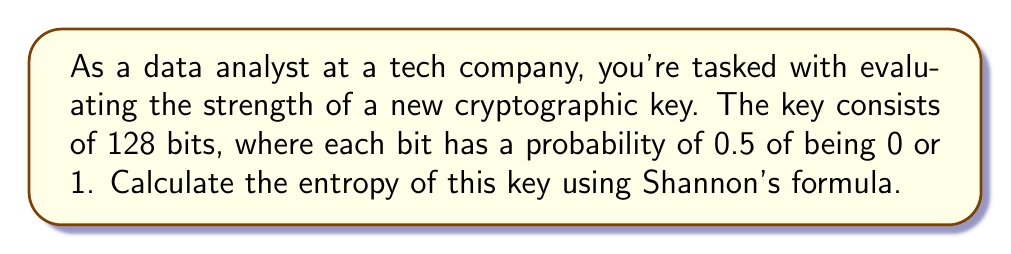Show me your answer to this math problem. To calculate the entropy of the cryptographic key, we'll use Shannon's formula:

$$H = -\sum_{i=1}^n p_i \log_2(p_i)$$

Where:
- $H$ is the entropy in bits
- $p_i$ is the probability of each possible outcome
- $n$ is the number of possible outcomes

For our key:
1. We have 128 bits
2. Each bit has two possible outcomes (0 or 1)
3. The probability of each outcome is 0.5

Let's apply the formula:

$$\begin{align*}
H &= -\sum_{i=1}^2 p_i \log_2(p_i) \\
&= -(0.5 \log_2(0.5) + 0.5 \log_2(0.5)) \\
&= -2(0.5 \log_2(0.5)) \\
&= -2(0.5 \cdot (-1)) \\
&= 1 \text{ bit per binary digit}
\end{align*}$$

Since we have 128 independent bits, we multiply the per-bit entropy by 128:

$$H_{total} = 128 \cdot 1 = 128 \text{ bits}$$

This result indicates that each bit contributes 1 bit of entropy, and with 128 bits, we have 128 bits of entropy in total, which is the maximum possible for a 128-bit key.
Answer: 128 bits 